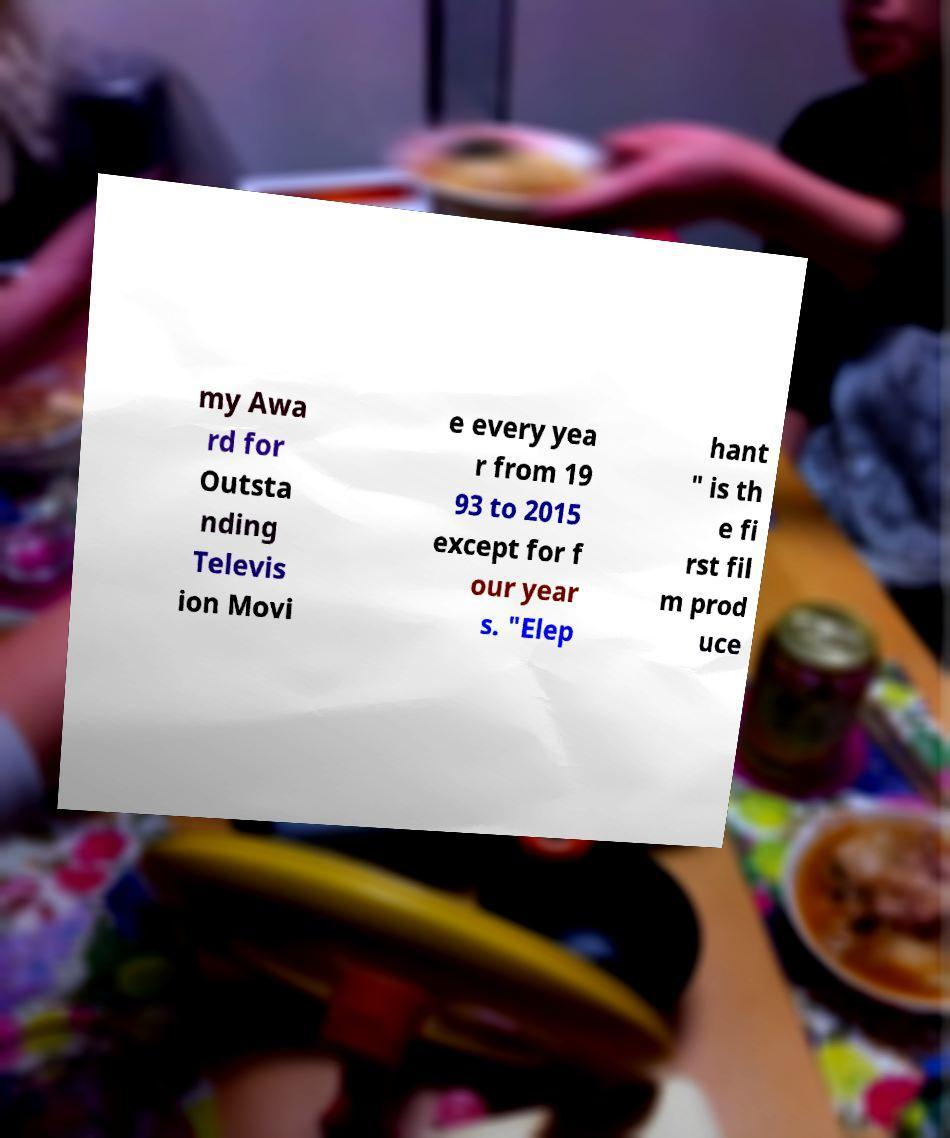Could you extract and type out the text from this image? my Awa rd for Outsta nding Televis ion Movi e every yea r from 19 93 to 2015 except for f our year s. "Elep hant " is th e fi rst fil m prod uce 